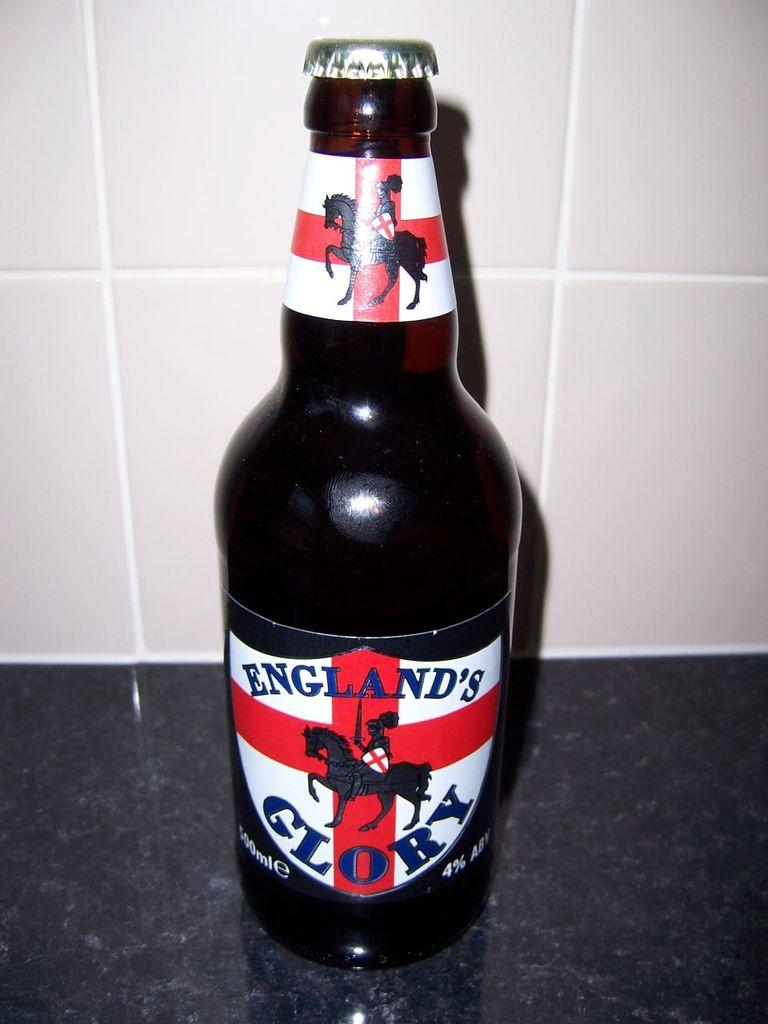<image>
Present a compact description of the photo's key features. A bottle of England's Glory sits on a granite counter 